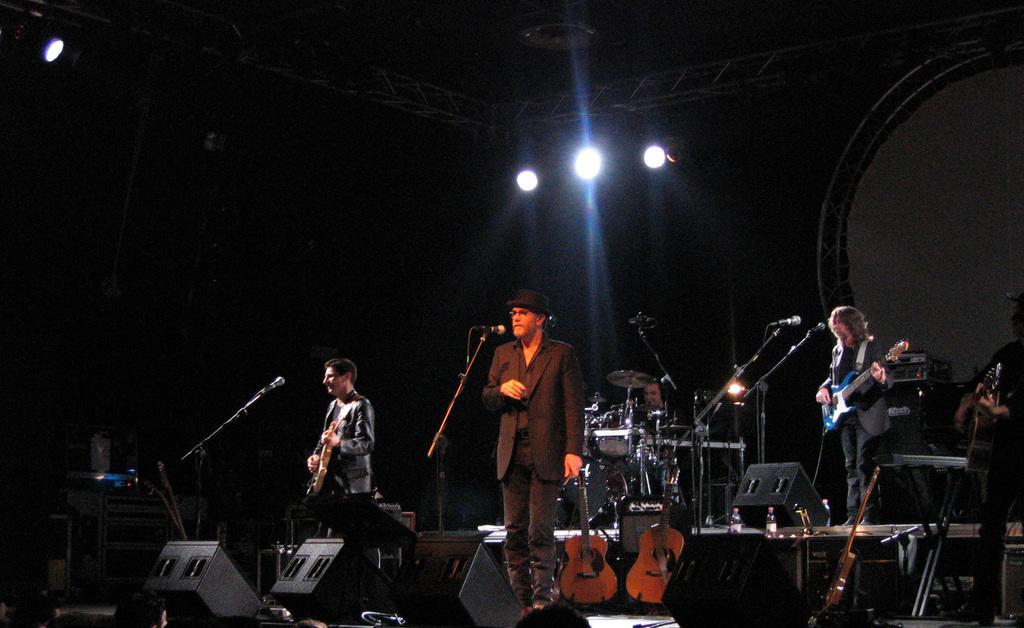In one or two sentences, can you explain what this image depicts? In this picture there are people standing they have microphones in front of them and the person standing on to the right is playing the guitar. 